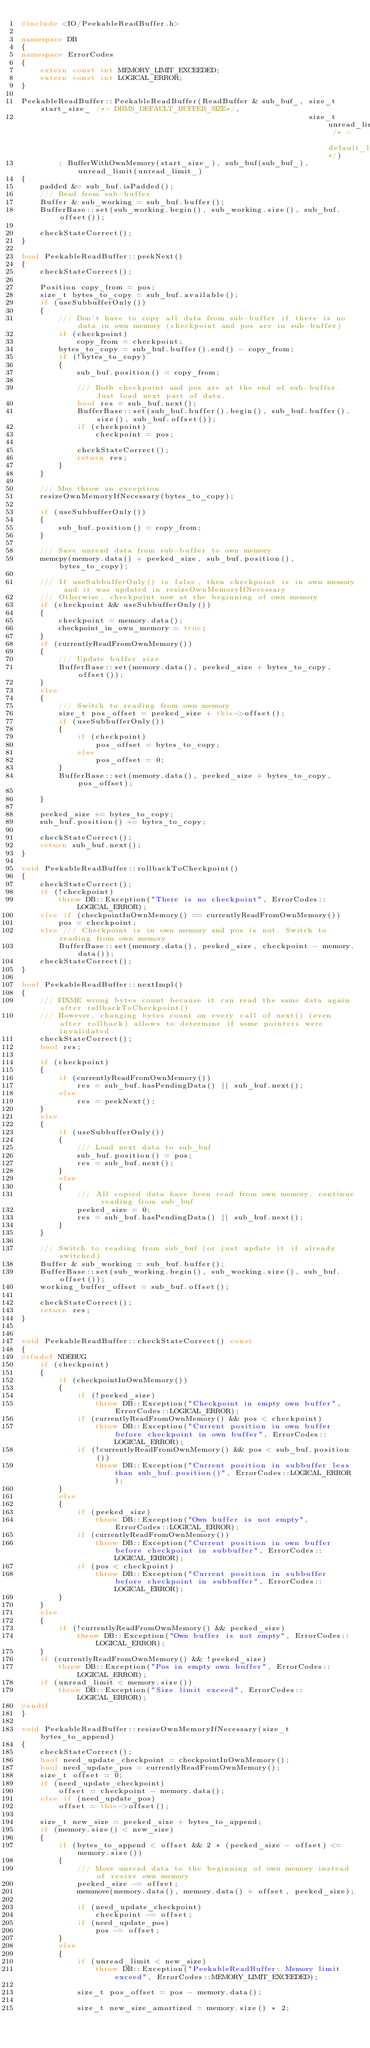Convert code to text. <code><loc_0><loc_0><loc_500><loc_500><_C++_>#include <IO/PeekableReadBuffer.h>

namespace DB
{
namespace ErrorCodes
{
    extern const int MEMORY_LIMIT_EXCEEDED;
    extern const int LOGICAL_ERROR;
}

PeekableReadBuffer::PeekableReadBuffer(ReadBuffer & sub_buf_, size_t start_size_ /*= DBMS_DEFAULT_BUFFER_SIZE*/,
                                                              size_t unread_limit_ /* = default_limit*/)
        : BufferWithOwnMemory(start_size_), sub_buf(sub_buf_), unread_limit(unread_limit_)
{
    padded &= sub_buf.isPadded();
    /// Read from sub-buffer
    Buffer & sub_working = sub_buf.buffer();
    BufferBase::set(sub_working.begin(), sub_working.size(), sub_buf.offset());

    checkStateCorrect();
}

bool PeekableReadBuffer::peekNext()
{
    checkStateCorrect();

    Position copy_from = pos;
    size_t bytes_to_copy = sub_buf.available();
    if (useSubbufferOnly())
    {
        /// Don't have to copy all data from sub-buffer if there is no data in own memory (checkpoint and pos are in sub-buffer)
        if (checkpoint)
            copy_from = checkpoint;
        bytes_to_copy = sub_buf.buffer().end() - copy_from;
        if (!bytes_to_copy)
        {
            sub_buf.position() = copy_from;

            /// Both checkpoint and pos are at the end of sub-buffer. Just load next part of data.
            bool res = sub_buf.next();
            BufferBase::set(sub_buf.buffer().begin(), sub_buf.buffer().size(), sub_buf.offset());
            if (checkpoint)
                checkpoint = pos;

            checkStateCorrect();
            return res;
        }
    }

    /// May throw an exception
    resizeOwnMemoryIfNecessary(bytes_to_copy);

    if (useSubbufferOnly())
    {
        sub_buf.position() = copy_from;
    }

    /// Save unread data from sub-buffer to own memory
    memcpy(memory.data() + peeked_size, sub_buf.position(), bytes_to_copy);

    /// If useSubbufferOnly() is false, then checkpoint is in own memory and it was updated in resizeOwnMemoryIfNecessary
    /// Otherwise, checkpoint now at the beginning of own memory
    if (checkpoint && useSubbufferOnly())
    {
        checkpoint = memory.data();
        checkpoint_in_own_memory = true;
    }
    if (currentlyReadFromOwnMemory())
    {
        /// Update buffer size
        BufferBase::set(memory.data(), peeked_size + bytes_to_copy, offset());
    }
    else
    {
        /// Switch to reading from own memory
        size_t pos_offset = peeked_size + this->offset();
        if (useSubbufferOnly())
        {
            if (checkpoint)
                pos_offset = bytes_to_copy;
            else
                pos_offset = 0;
        }
        BufferBase::set(memory.data(), peeked_size + bytes_to_copy, pos_offset);

    }

    peeked_size += bytes_to_copy;
    sub_buf.position() += bytes_to_copy;

    checkStateCorrect();
    return sub_buf.next();
}

void PeekableReadBuffer::rollbackToCheckpoint()
{
    checkStateCorrect();
    if (!checkpoint)
        throw DB::Exception("There is no checkpoint", ErrorCodes::LOGICAL_ERROR);
    else if (checkpointInOwnMemory() == currentlyReadFromOwnMemory())
        pos = checkpoint;
    else /// Checkpoint is in own memory and pos is not. Switch to reading from own memory
        BufferBase::set(memory.data(), peeked_size, checkpoint - memory.data());
    checkStateCorrect();
}

bool PeekableReadBuffer::nextImpl()
{
    /// FIXME wrong bytes count because it can read the same data again after rollbackToCheckpoint()
    /// However, changing bytes count on every call of next() (even after rollback) allows to determine if some pointers were invalidated.
    checkStateCorrect();
    bool res;

    if (checkpoint)
    {
        if (currentlyReadFromOwnMemory())
            res = sub_buf.hasPendingData() || sub_buf.next();
        else
            res = peekNext();
    }
    else
    {
        if (useSubbufferOnly())
        {
            /// Load next data to sub_buf
            sub_buf.position() = pos;
            res = sub_buf.next();
        }
        else
        {
            /// All copied data have been read from own memory, continue reading from sub_buf
            peeked_size = 0;
            res = sub_buf.hasPendingData() || sub_buf.next();
        }
    }

    /// Switch to reading from sub_buf (or just update it if already switched)
    Buffer & sub_working = sub_buf.buffer();
    BufferBase::set(sub_working.begin(), sub_working.size(), sub_buf.offset());
    working_buffer_offset = sub_buf.offset();

    checkStateCorrect();
    return res;
}


void PeekableReadBuffer::checkStateCorrect() const
{
#ifndef NDEBUG
    if (checkpoint)
    {
        if (checkpointInOwnMemory())
        {
            if (!peeked_size)
                throw DB::Exception("Checkpoint in empty own buffer", ErrorCodes::LOGICAL_ERROR);
            if (currentlyReadFromOwnMemory() && pos < checkpoint)
                throw DB::Exception("Current position in own buffer before checkpoint in own buffer", ErrorCodes::LOGICAL_ERROR);
            if (!currentlyReadFromOwnMemory() && pos < sub_buf.position())
                throw DB::Exception("Current position in subbuffer less than sub_buf.position()", ErrorCodes::LOGICAL_ERROR);
        }
        else
        {
            if (peeked_size)
                throw DB::Exception("Own buffer is not empty", ErrorCodes::LOGICAL_ERROR);
            if (currentlyReadFromOwnMemory())
                throw DB::Exception("Current position in own buffer before checkpoint in subbuffer", ErrorCodes::LOGICAL_ERROR);
            if (pos < checkpoint)
                throw DB::Exception("Current position in subbuffer before checkpoint in subbuffer", ErrorCodes::LOGICAL_ERROR);
        }
    }
    else
    {
        if (!currentlyReadFromOwnMemory() && peeked_size)
            throw DB::Exception("Own buffer is not empty", ErrorCodes::LOGICAL_ERROR);
    }
    if (currentlyReadFromOwnMemory() && !peeked_size)
        throw DB::Exception("Pos in empty own buffer", ErrorCodes::LOGICAL_ERROR);
    if (unread_limit < memory.size())
        throw DB::Exception("Size limit exceed", ErrorCodes::LOGICAL_ERROR);
#endif
}

void PeekableReadBuffer::resizeOwnMemoryIfNecessary(size_t bytes_to_append)
{
    checkStateCorrect();
    bool need_update_checkpoint = checkpointInOwnMemory();
    bool need_update_pos = currentlyReadFromOwnMemory();
    size_t offset = 0;
    if (need_update_checkpoint)
        offset = checkpoint - memory.data();
    else if (need_update_pos)
        offset = this->offset();

    size_t new_size = peeked_size + bytes_to_append;
    if (memory.size() < new_size)
    {
        if (bytes_to_append < offset && 2 * (peeked_size - offset) <= memory.size())
        {
            /// Move unread data to the beginning of own memory instead of resize own memory
            peeked_size -= offset;
            memmove(memory.data(), memory.data() + offset, peeked_size);

            if (need_update_checkpoint)
                checkpoint -= offset;
            if (need_update_pos)
                pos -= offset;
        }
        else
        {
            if (unread_limit < new_size)
                throw DB::Exception("PeekableReadBuffer: Memory limit exceed", ErrorCodes::MEMORY_LIMIT_EXCEEDED);

            size_t pos_offset = pos - memory.data();

            size_t new_size_amortized = memory.size() * 2;</code> 